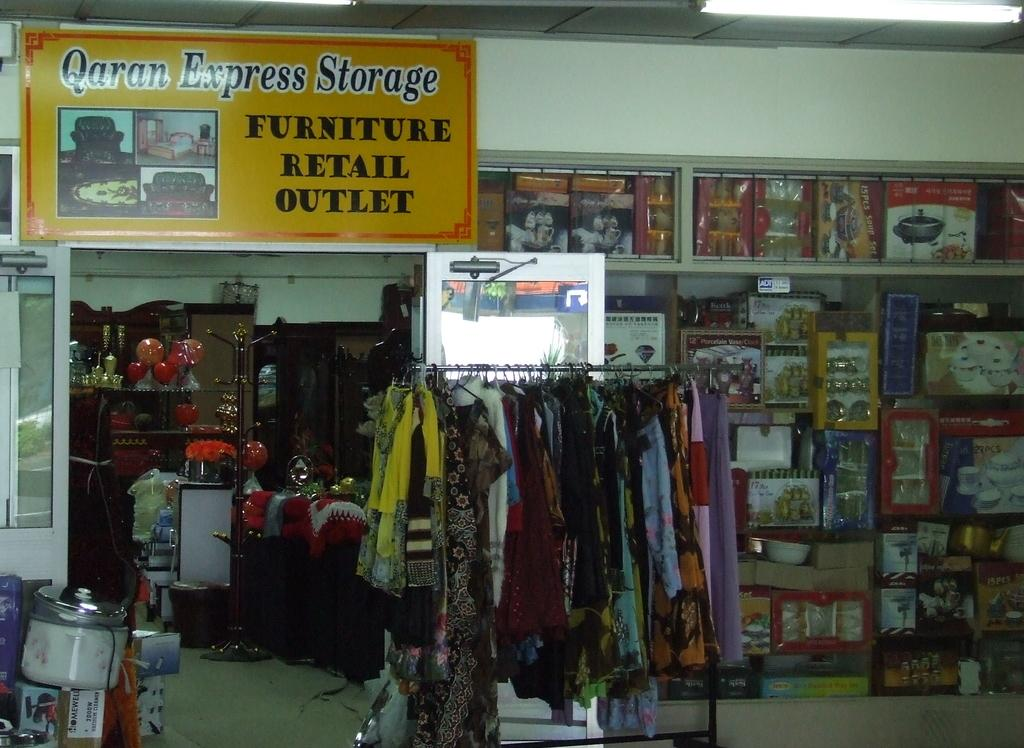<image>
Summarize the visual content of the image. The front of a store with a sign that says Qaran Express Furniture Retail Outlet on it. 